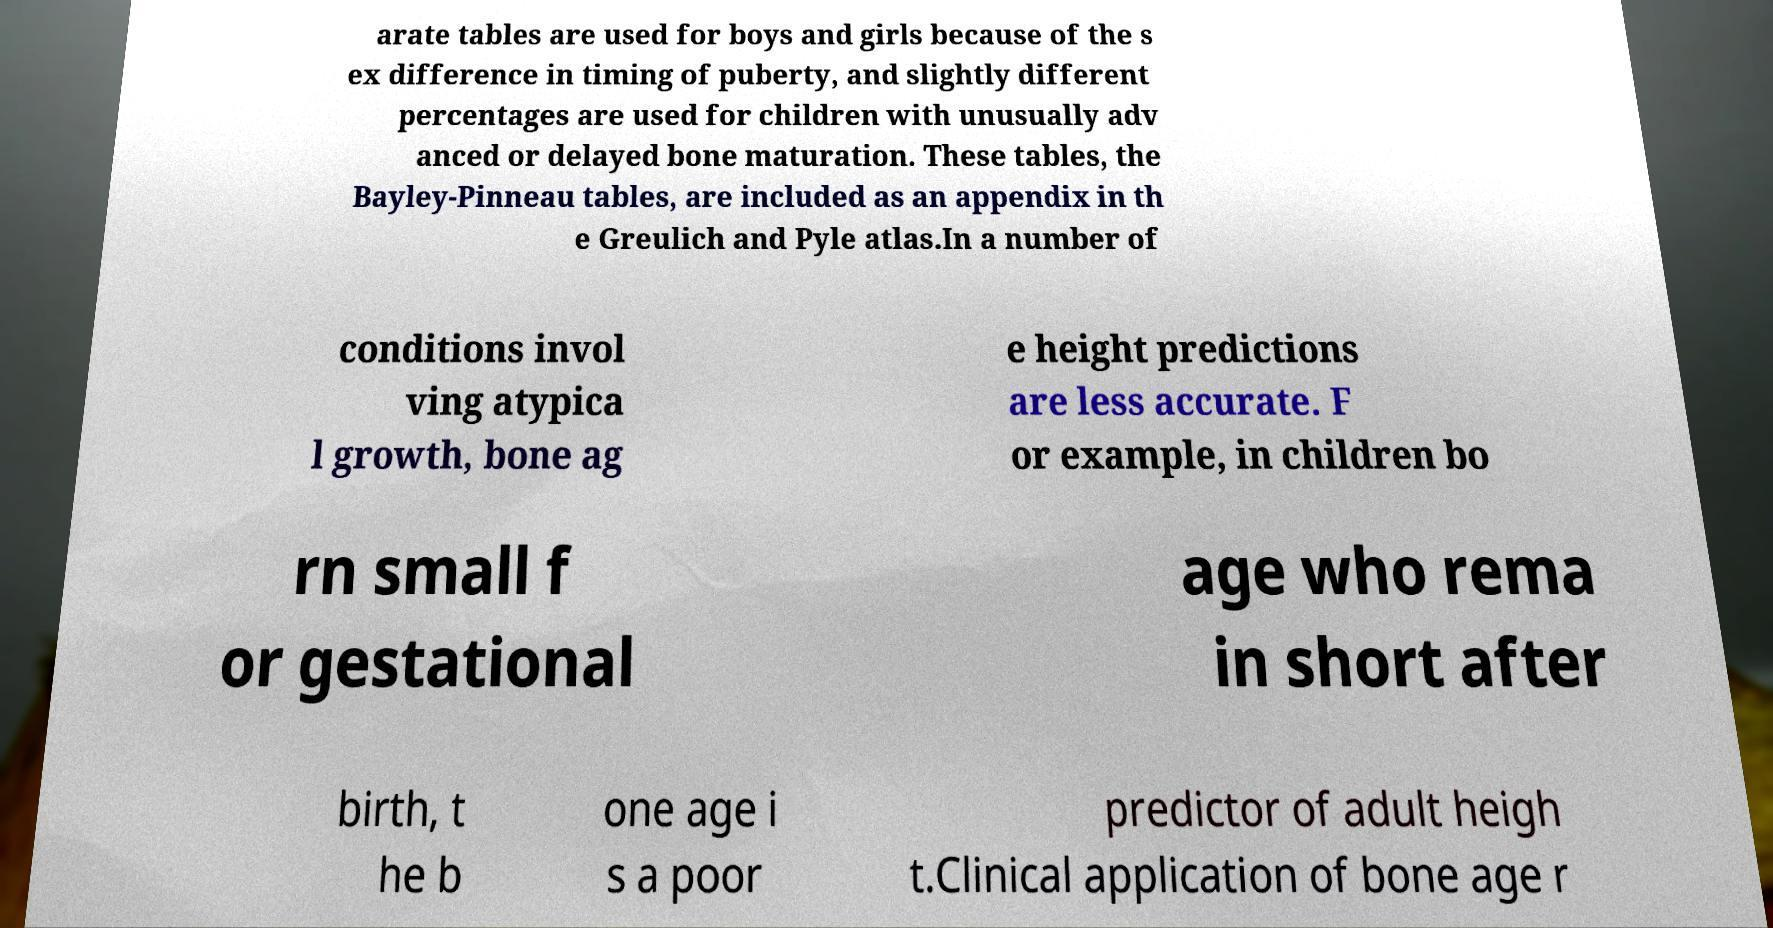Can you accurately transcribe the text from the provided image for me? arate tables are used for boys and girls because of the s ex difference in timing of puberty, and slightly different percentages are used for children with unusually adv anced or delayed bone maturation. These tables, the Bayley-Pinneau tables, are included as an appendix in th e Greulich and Pyle atlas.In a number of conditions invol ving atypica l growth, bone ag e height predictions are less accurate. F or example, in children bo rn small f or gestational age who rema in short after birth, t he b one age i s a poor predictor of adult heigh t.Clinical application of bone age r 